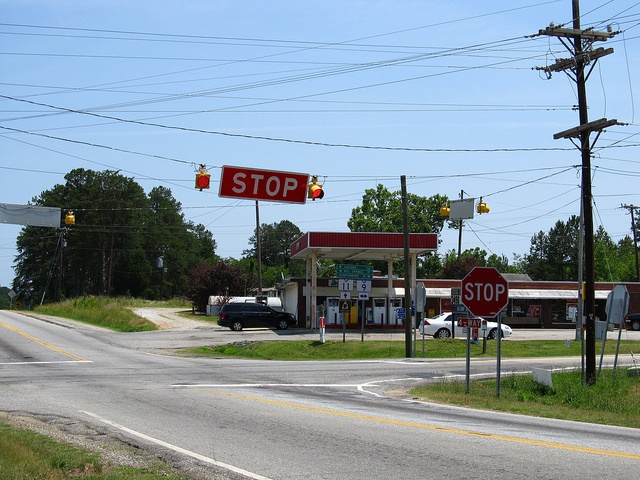Describe the objects in this image and their specific colors. I can see stop sign in lightblue, maroon, gray, and darkgray tones, car in lightblue, black, gray, and maroon tones, car in lightblue, black, darkgray, white, and gray tones, stop sign in lightblue, gray, blue, and black tones, and car in lightblue, black, gray, and maroon tones in this image. 